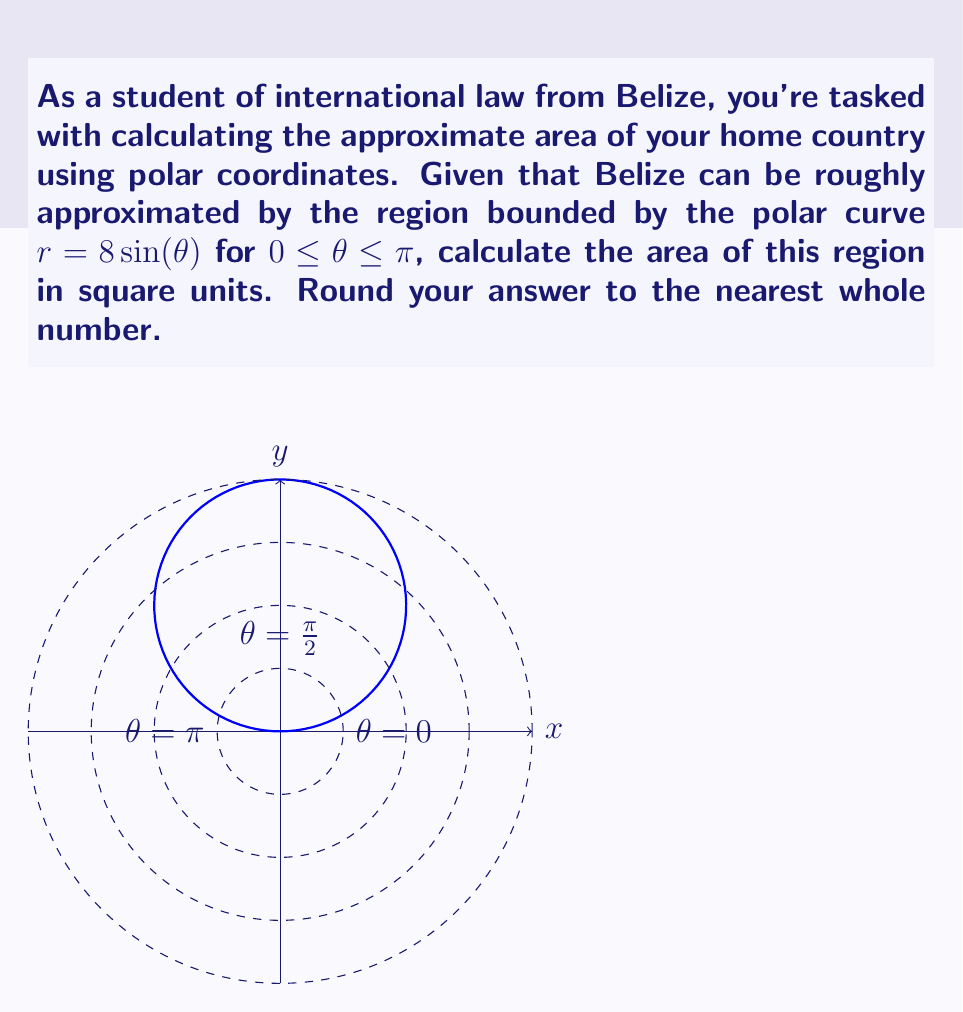Can you answer this question? To calculate the area bounded by a polar curve, we use the formula:

$$ A = \frac{1}{2} \int_{a}^{b} r^2(\theta) d\theta $$

Where $r(\theta)$ is the given polar function and $a$ and $b$ are the lower and upper bounds of $\theta$, respectively.

Step 1: Identify the function and bounds
$r(\theta) = 8\sin(\theta)$
$a = 0$, $b = \pi$

Step 2: Square the function
$r^2(\theta) = (8\sin(\theta))^2 = 64\sin^2(\theta)$

Step 3: Set up the integral
$$ A = \frac{1}{2} \int_{0}^{\pi} 64\sin^2(\theta) d\theta $$

Step 4: Evaluate the integral
Using the identity $\sin^2(\theta) = \frac{1 - \cos(2\theta)}{2}$, we get:

$$ \begin{align*}
A &= \frac{1}{2} \int_{0}^{\pi} 64 \cdot \frac{1 - \cos(2\theta)}{2} d\theta \\
&= 16 \int_{0}^{\pi} (1 - \cos(2\theta)) d\theta \\
&= 16 \left[ \theta - \frac{1}{2}\sin(2\theta) \right]_{0}^{\pi} \\
&= 16 \left[ \pi - 0 - (\frac{1}{2}\sin(2\pi) - \frac{1}{2}\sin(0)) \right] \\
&= 16\pi
\end{align*} $$

Step 5: Round to the nearest whole number
$16\pi \approx 50.27$, which rounds to 50 square units.
Answer: 50 square units 